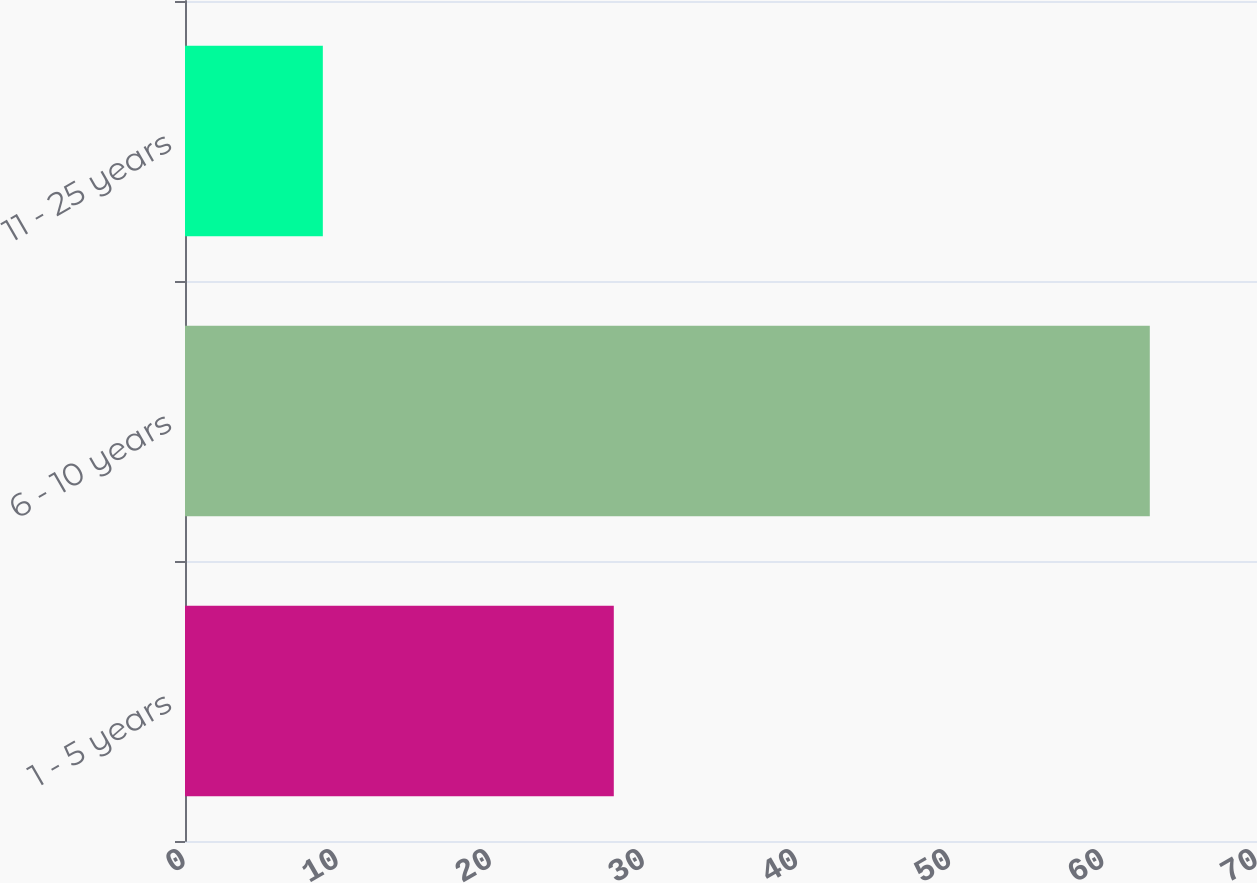Convert chart. <chart><loc_0><loc_0><loc_500><loc_500><bar_chart><fcel>1 - 5 years<fcel>6 - 10 years<fcel>11 - 25 years<nl><fcel>28<fcel>63<fcel>9<nl></chart> 